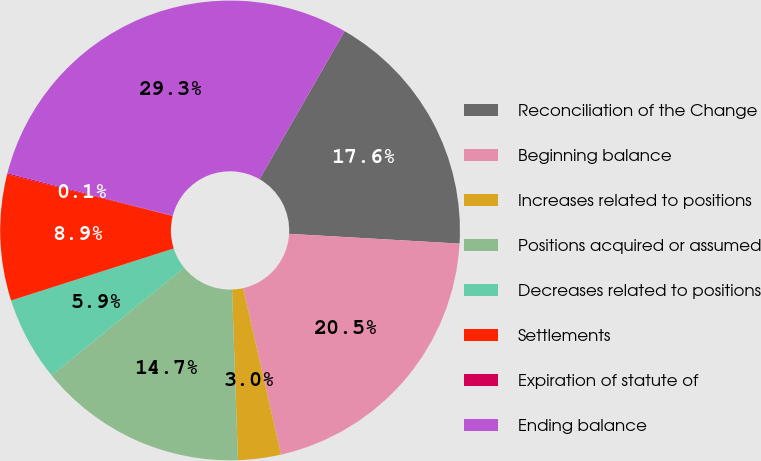Convert chart. <chart><loc_0><loc_0><loc_500><loc_500><pie_chart><fcel>Reconciliation of the Change<fcel>Beginning balance<fcel>Increases related to positions<fcel>Positions acquired or assumed<fcel>Decreases related to positions<fcel>Settlements<fcel>Expiration of statute of<fcel>Ending balance<nl><fcel>17.61%<fcel>20.53%<fcel>3.01%<fcel>14.69%<fcel>5.93%<fcel>8.85%<fcel>0.08%<fcel>29.3%<nl></chart> 